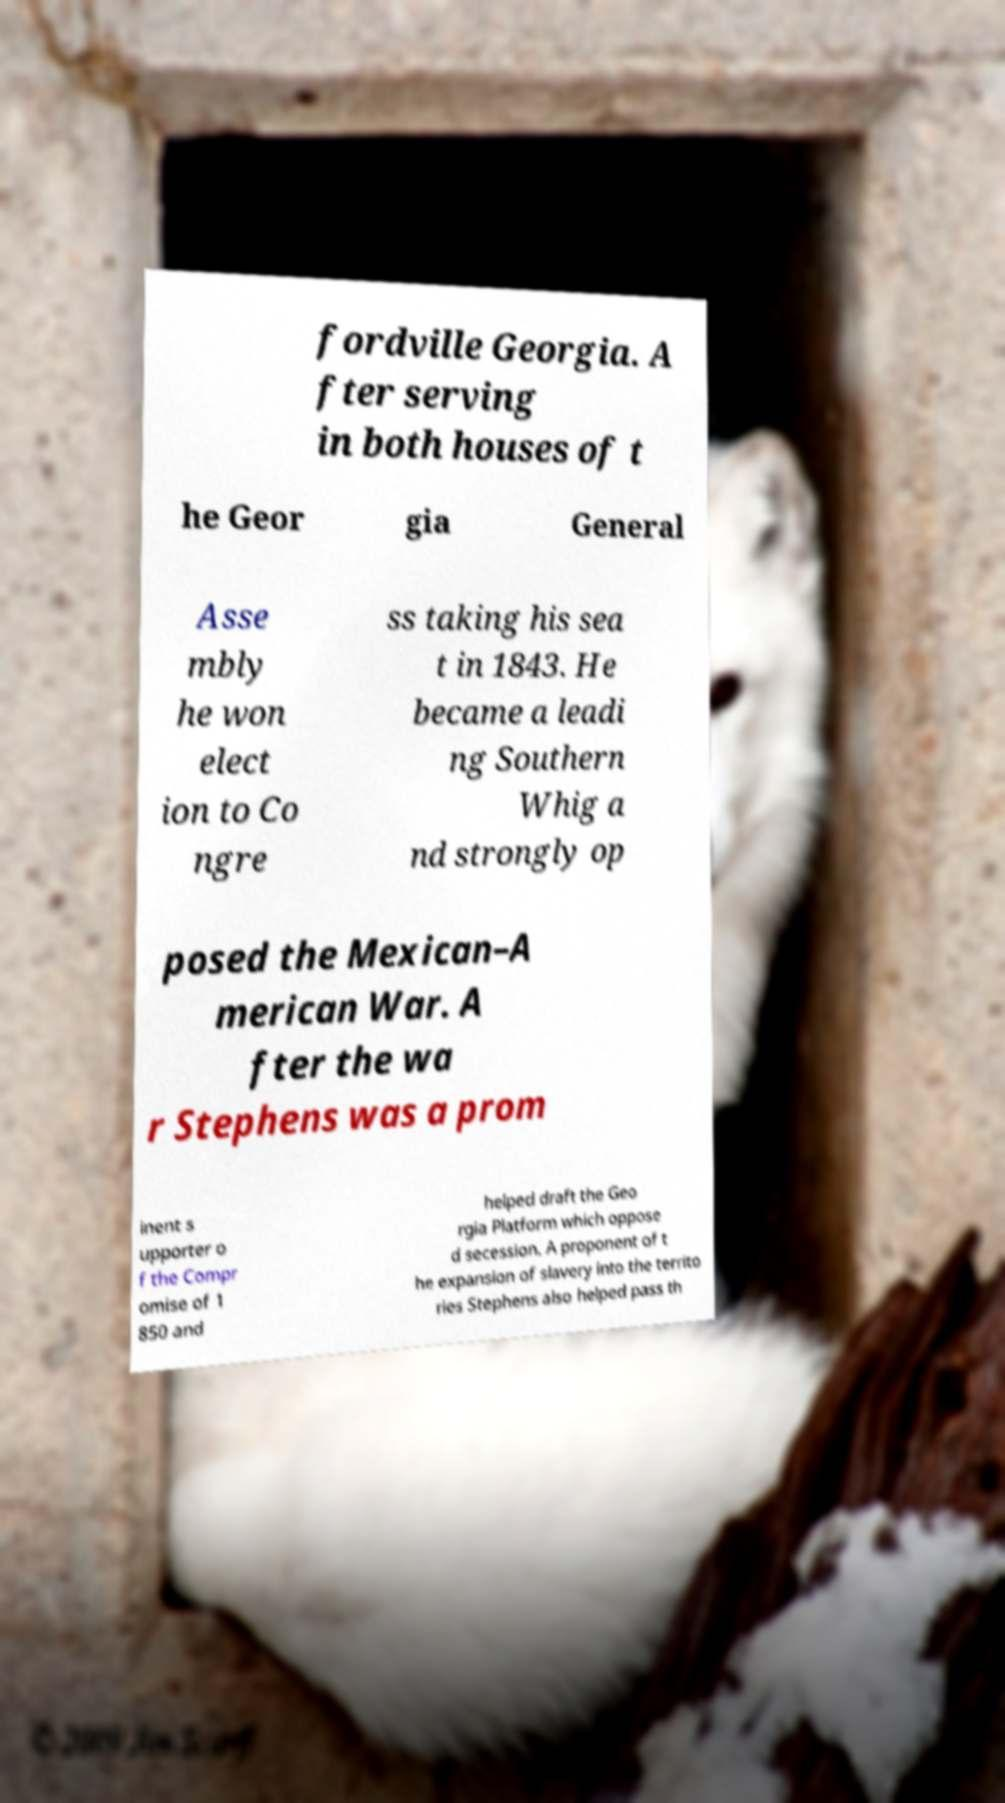Please read and relay the text visible in this image. What does it say? fordville Georgia. A fter serving in both houses of t he Geor gia General Asse mbly he won elect ion to Co ngre ss taking his sea t in 1843. He became a leadi ng Southern Whig a nd strongly op posed the Mexican–A merican War. A fter the wa r Stephens was a prom inent s upporter o f the Compr omise of 1 850 and helped draft the Geo rgia Platform which oppose d secession. A proponent of t he expansion of slavery into the territo ries Stephens also helped pass th 